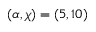<formula> <loc_0><loc_0><loc_500><loc_500>( \alpha , \chi ) = ( 5 , 1 0 )</formula> 